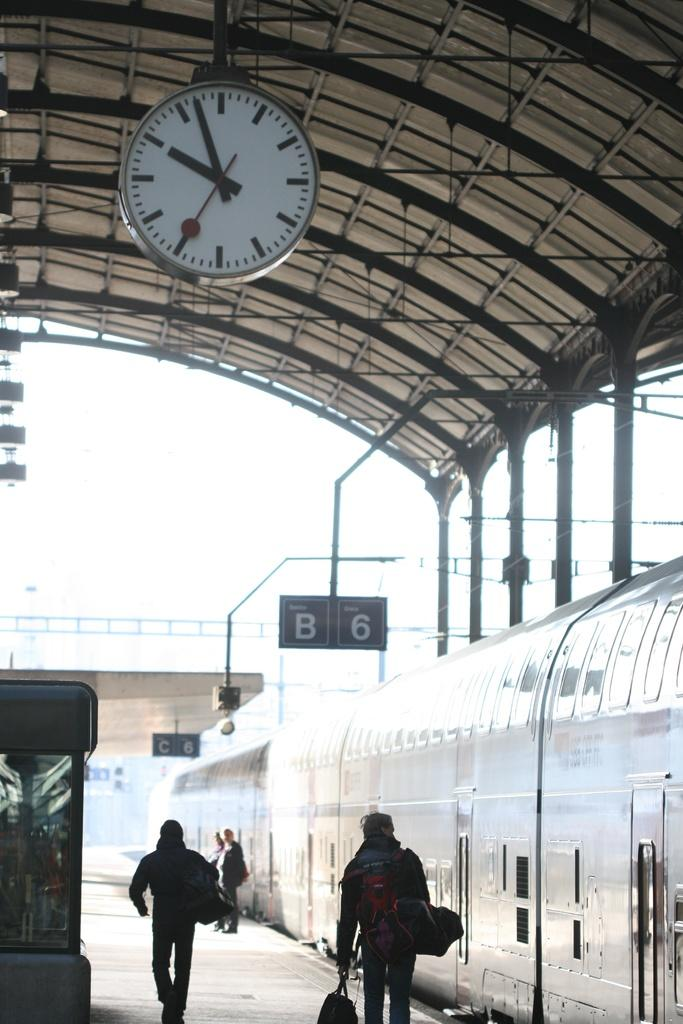<image>
Create a compact narrative representing the image presented. A few people are walking on train platform B6 and C6. 